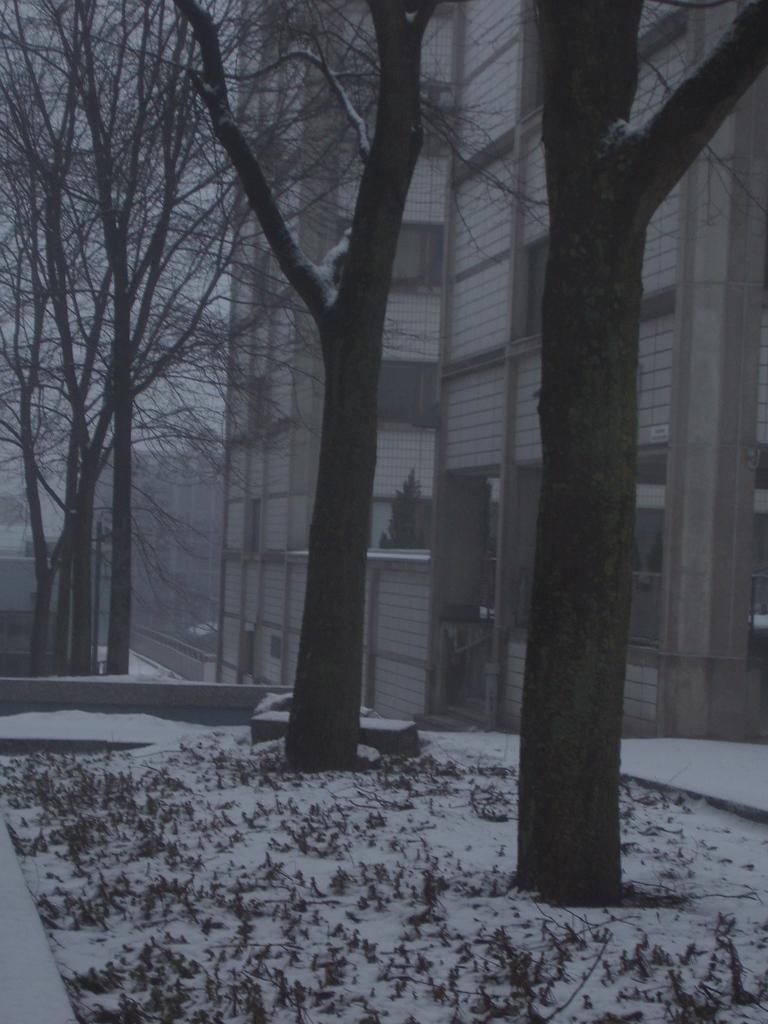Can you describe this image briefly? In this image we can see many trees. Behind the trees we can see the buildings. In the top left, we can see the sky. At the bottom we can see the grass and the snow. 